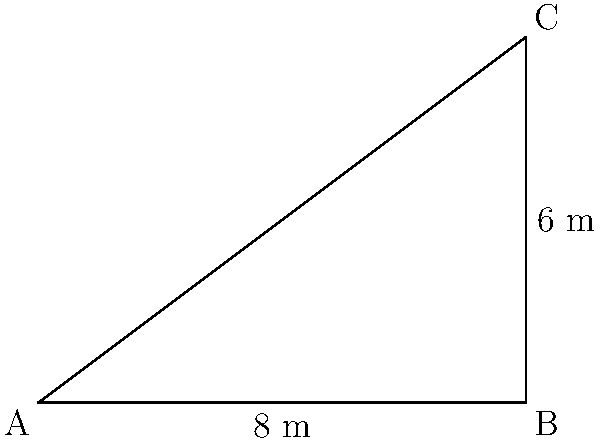In a converted attic studio, you need to determine the pitch angle of the sloped ceiling for your sibling's design project. The horizontal distance from the wall to the peak of the roof is 8 meters, and the vertical height from the floor to the peak is 6 meters. What is the pitch angle $\theta$ of the sloped ceiling? To find the pitch angle of the sloped ceiling, we can use trigonometry. The problem presents us with a right triangle, where:

1. The base (horizontal distance) is 8 meters
2. The height (vertical distance) is 6 meters
3. The hypotenuse represents the sloped ceiling
4. The angle $\theta$ is what we need to find

We can use the tangent function to solve for $\theta$:

$\tan(\theta) = \frac{\text{opposite}}{\text{adjacent}} = \frac{\text{height}}{\text{base}}$

$\tan(\theta) = \frac{6}{8} = 0.75$

To find $\theta$, we need to use the inverse tangent (arctan or $\tan^{-1}$):

$\theta = \tan^{-1}(0.75)$

Using a calculator or trigonometric tables:

$\theta \approx 36.87^\circ$

Therefore, the pitch angle of the sloped ceiling is approximately 36.87 degrees.
Answer: $36.87^\circ$ 